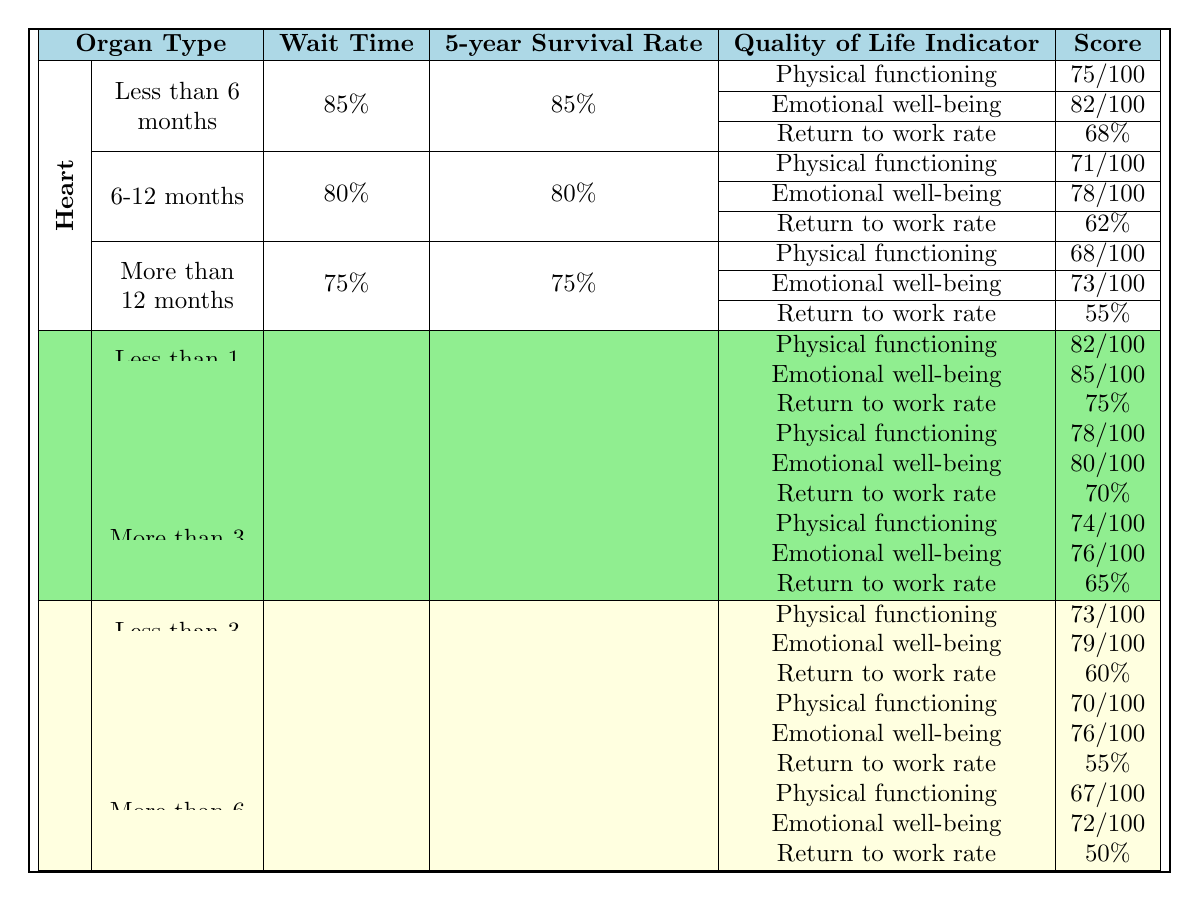What is the 5-year survival rate for heart transplant patients who waited less than 6 months? The table indicates that the 5-year survival rate for heart transplant patients in the “Less than 6 months” wait time category is 85%.
Answer: 85% Which organ type has the highest 5-year survival rate among patients who waited more than 12 months? Among the organs listed, the 5-year survival rate for heart transplant patients who waited more than 12 months is 75%, while for kidney it is 85%, and for liver it is 72%. The kidney has the highest survival rate.
Answer: Kidney What is the return to work rate for kidney transplant patients who waited between 1 to 3 years? According to the table, the return to work rate for kidney transplant patients in the “1-3 years” wait time category is 70%.
Answer: 70% Is the emotional well-being score for liver transplant patients who waited less than 3 months higher than that for patients who waited 3-6 months? The emotional well-being score for liver transplant patients who waited less than 3 months is 79, while the score for those who waited 3-6 months is 76. Therefore, the score for patients who waited less than 3 months is indeed higher.
Answer: Yes What is the average physical functioning score for heart transplant patients across all wait time categories? The physical functioning scores for heart transplant patients are 75, 71, and 68 for the respective wait categories. The average is (75 + 71 + 68) / 3 = 214 / 3 = 71.33.
Answer: 71.33 How much lower is the return to work rate for liver transplant patients who waited more than 6 months compared to those who waited less than 3 months? For liver transplant patients, the return to work rate is 50% for those who waited more than 6 months and 60% for those who waited less than 3 months. The difference is 60% - 50% = 10%.
Answer: 10% Which quality of life indicator had the lowest score for heart transplant patients waiting over 12 months? For heart transplant patients who waited more than 12 months, the quality of life indicators are: Physical functioning (68), Emotional well-being (73), Return to work rate (55). The lowest score is for the Return to work rate, which is 55%.
Answer: Return to work rate How do the 5-year survival rates compare between kidney transplant patients who waited less than 1 year and those who waited more than 3 years? The 5-year survival rate for kidney transplant patients who waited less than 1 year is 92%, whereas for those who waited more than 3 years it is 85%. The survival rate is higher for those who waited less than 1 year.
Answer: Higher for less than 1 year What is the difference in physical functioning scores between kidney transplant patients who waited less than 1 year and those who waited 1-3 years? The physical functioning score for kidney transplant patients who waited less than 1 year is 82, and for those who waited 1-3 years, it is 78. The difference is 82 - 78 = 4.
Answer: 4 True or False: The emotional well-being score for kidney transplant patients who waited less than 1 year is higher than the score for heart transplant patients who waited 6-12 months. The emotional well-being score for kidney transplant patients who waited less than 1 year is 85, while for heart transplant patients who waited 6-12 months, it is 78. Thus, the statement is true.
Answer: True 